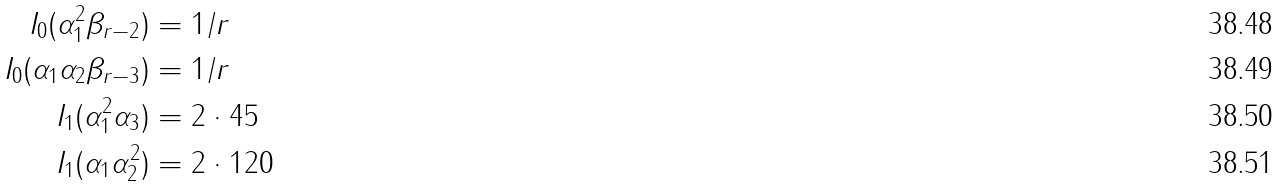Convert formula to latex. <formula><loc_0><loc_0><loc_500><loc_500>I _ { 0 } ( \alpha _ { 1 } ^ { 2 } \beta _ { r - 2 } ) & = 1 / r \\ I _ { 0 } ( \alpha _ { 1 } \alpha _ { 2 } \beta _ { r - 3 } ) & = 1 / r \\ I _ { 1 } ( \alpha _ { 1 } ^ { 2 } \alpha _ { 3 } ) & = 2 \cdot 4 5 \\ I _ { 1 } ( \alpha _ { 1 } \alpha _ { 2 } ^ { 2 } ) & = 2 \cdot 1 2 0</formula> 